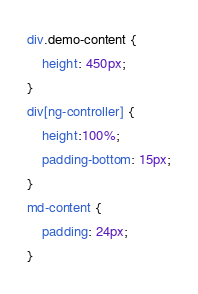<code> <loc_0><loc_0><loc_500><loc_500><_CSS_>
div.demo-content {
    height: 450px;
}
div[ng-controller] {
    height:100%;
    padding-bottom: 15px;
}
md-content {
    padding: 24px;
}
</code> 